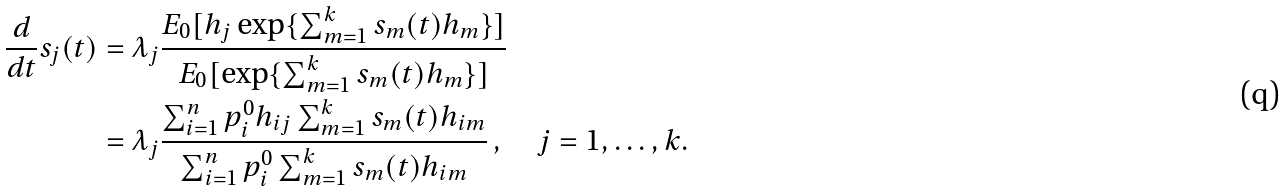Convert formula to latex. <formula><loc_0><loc_0><loc_500><loc_500>\frac { d } { d t } s _ { j } ( t ) & = \lambda _ { j } \frac { E _ { 0 } [ h _ { j } \exp \{ \sum \nolimits _ { m = 1 } ^ { k } s _ { m } ( t ) h _ { m } \} ] } { E _ { 0 } [ \exp \{ \sum \nolimits _ { m = 1 } ^ { k } s _ { m } ( t ) h _ { m } \} ] } \\ & = \lambda _ { j } \frac { \sum \nolimits _ { i = 1 } ^ { n } p _ { i } ^ { 0 } h _ { i j } \sum \nolimits _ { m = 1 } ^ { k } s _ { m } ( t ) h _ { i m } } { \sum \nolimits _ { i = 1 } ^ { n } p _ { i } ^ { 0 } \sum \nolimits _ { m = 1 } ^ { k } s _ { m } ( t ) h _ { i m } } \, , \quad j = 1 , \dots , k .</formula> 